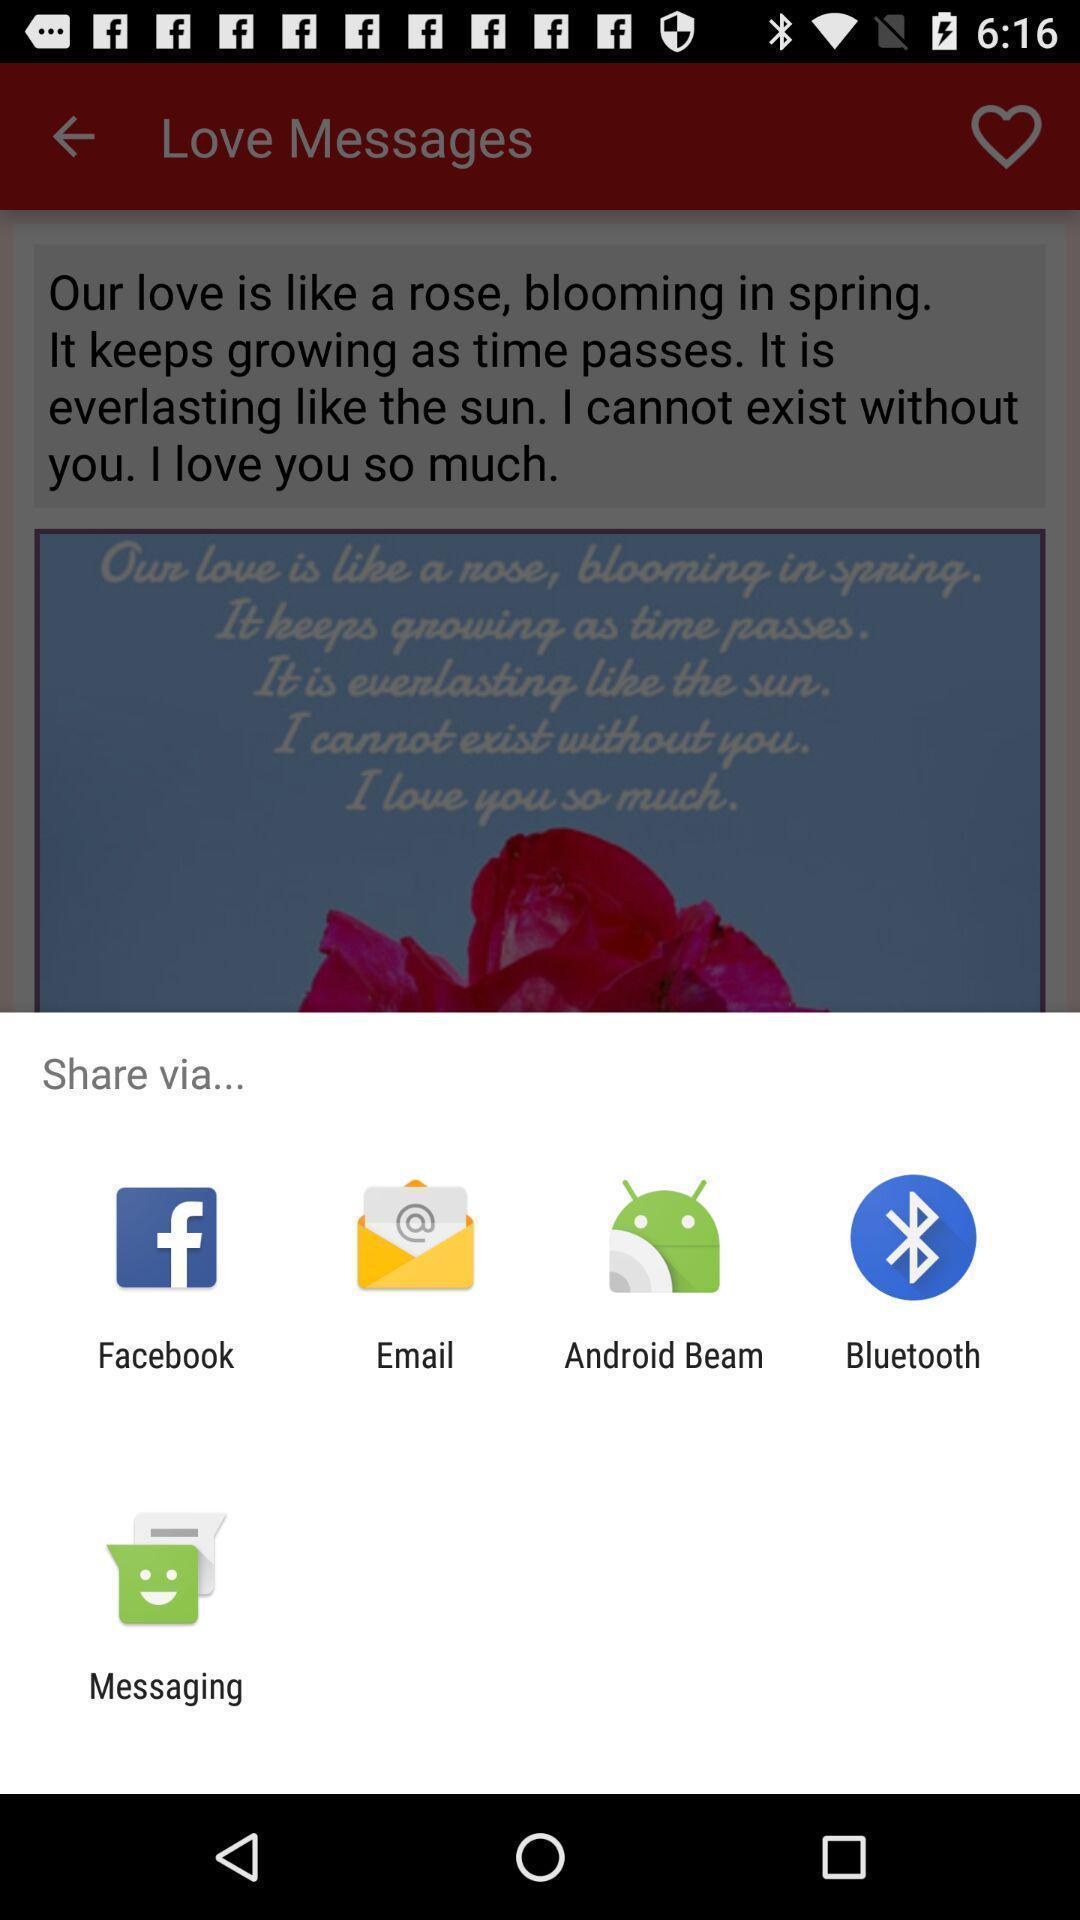What is the overall content of this screenshot? Pop-up showing the multiple share options. 